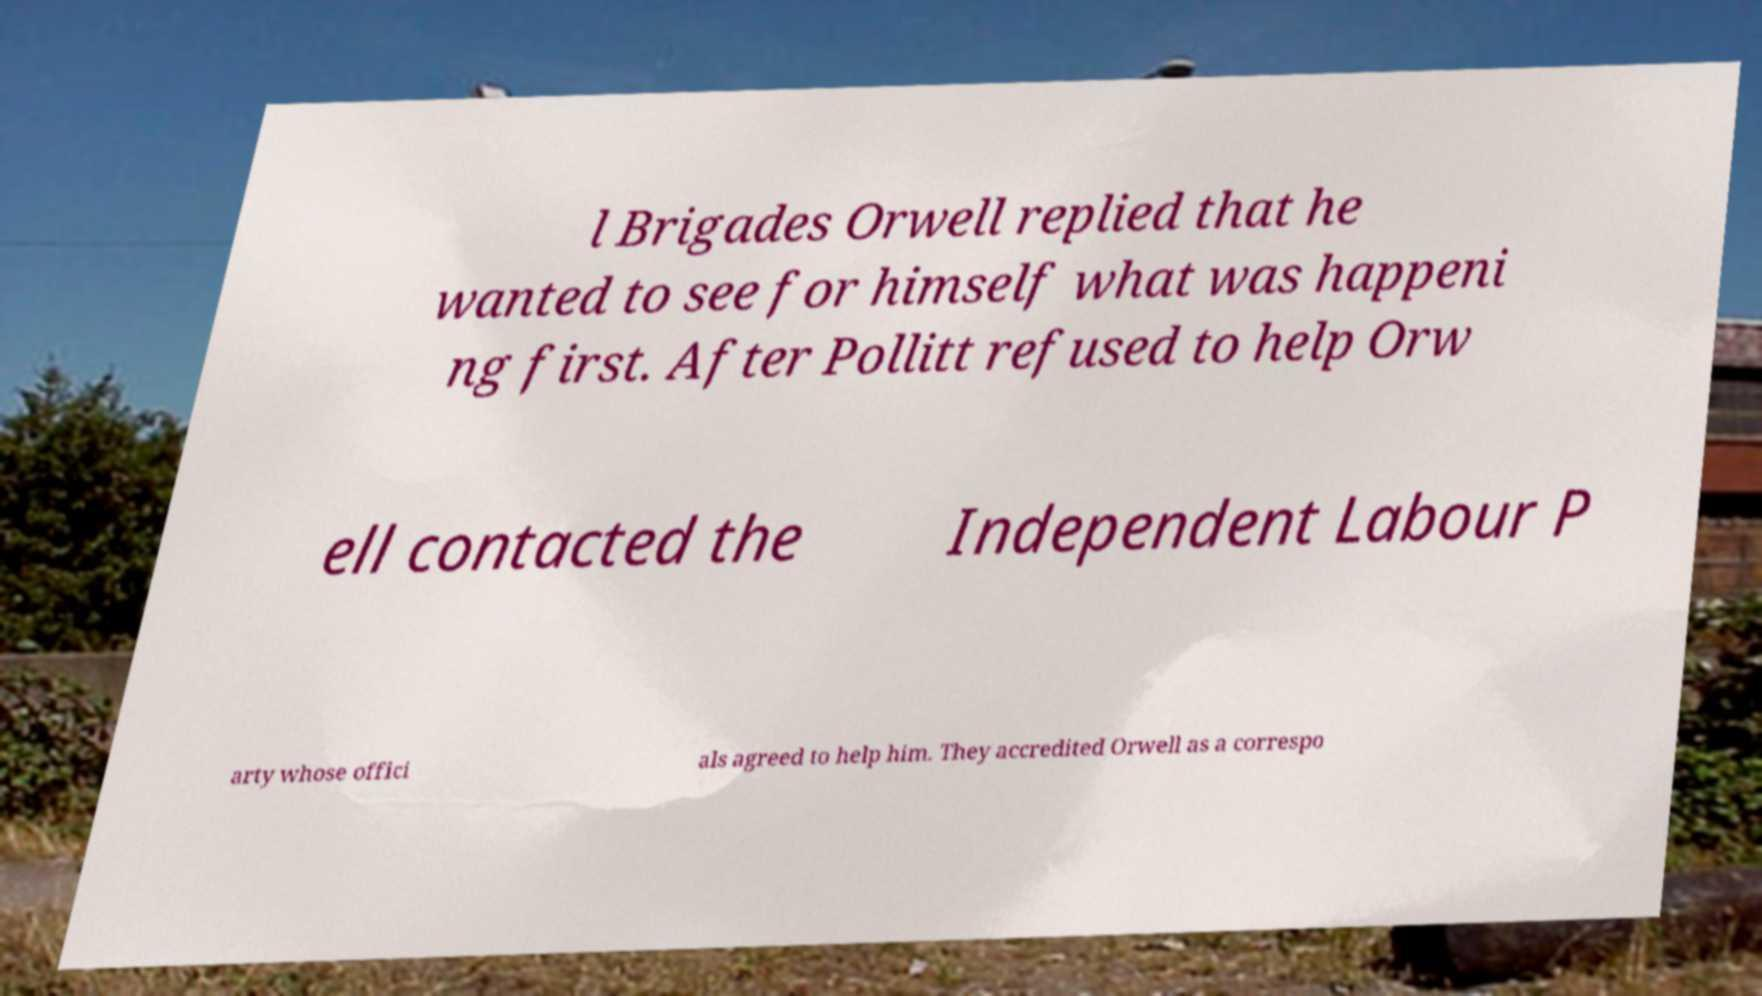Could you extract and type out the text from this image? l Brigades Orwell replied that he wanted to see for himself what was happeni ng first. After Pollitt refused to help Orw ell contacted the Independent Labour P arty whose offici als agreed to help him. They accredited Orwell as a correspo 